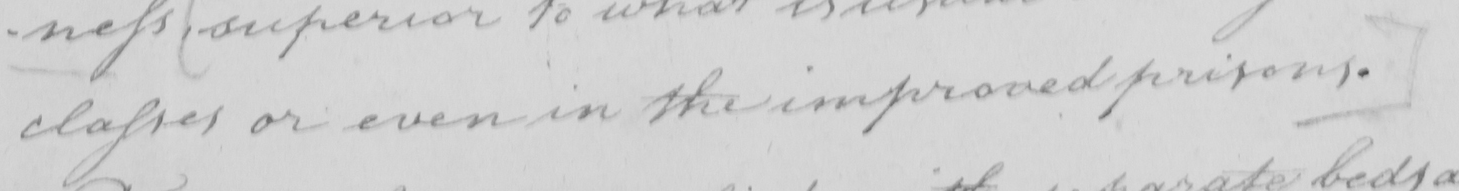What does this handwritten line say? classes or even in the improved prisons . ] 